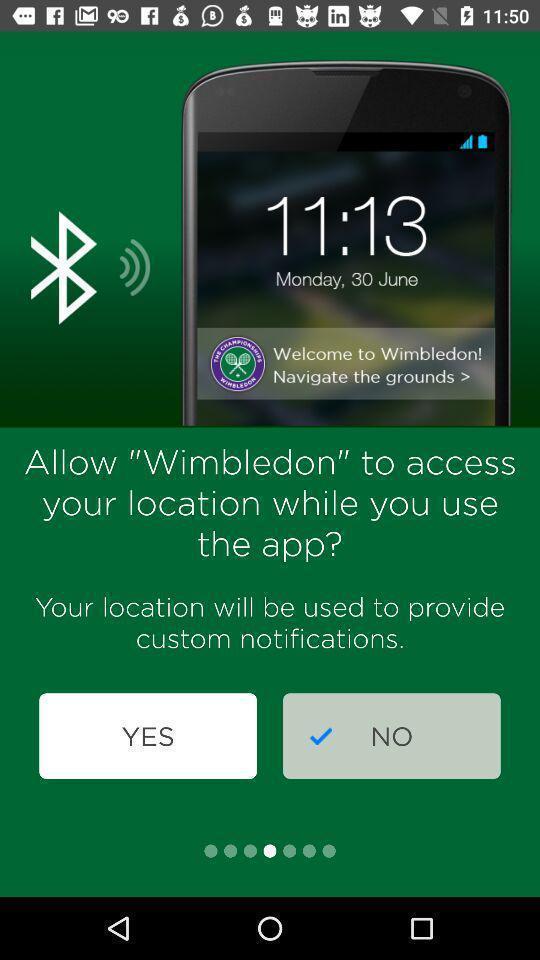Give me a summary of this screen capture. Page requesting to use the location of the app. 